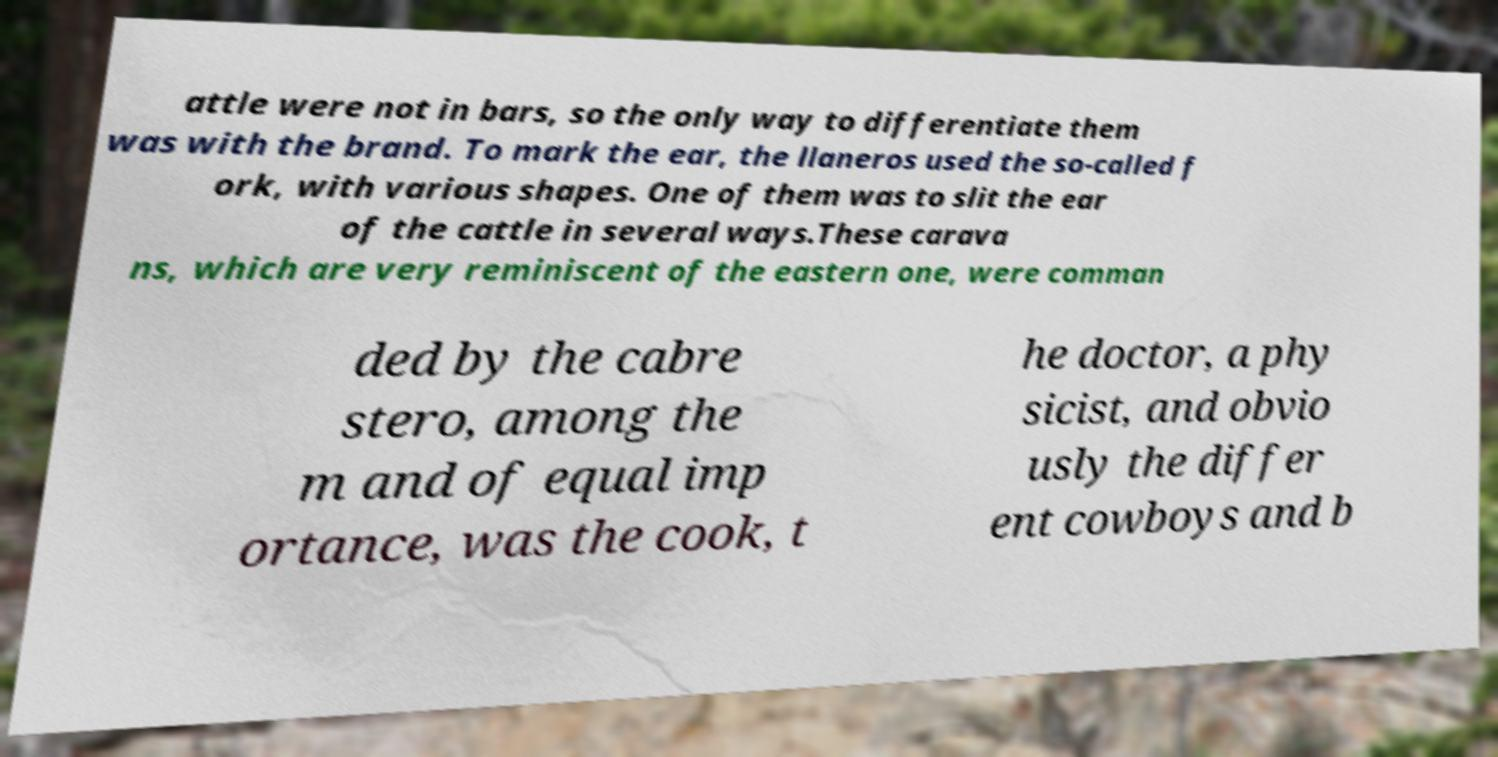Could you extract and type out the text from this image? attle were not in bars, so the only way to differentiate them was with the brand. To mark the ear, the llaneros used the so-called f ork, with various shapes. One of them was to slit the ear of the cattle in several ways.These carava ns, which are very reminiscent of the eastern one, were comman ded by the cabre stero, among the m and of equal imp ortance, was the cook, t he doctor, a phy sicist, and obvio usly the differ ent cowboys and b 